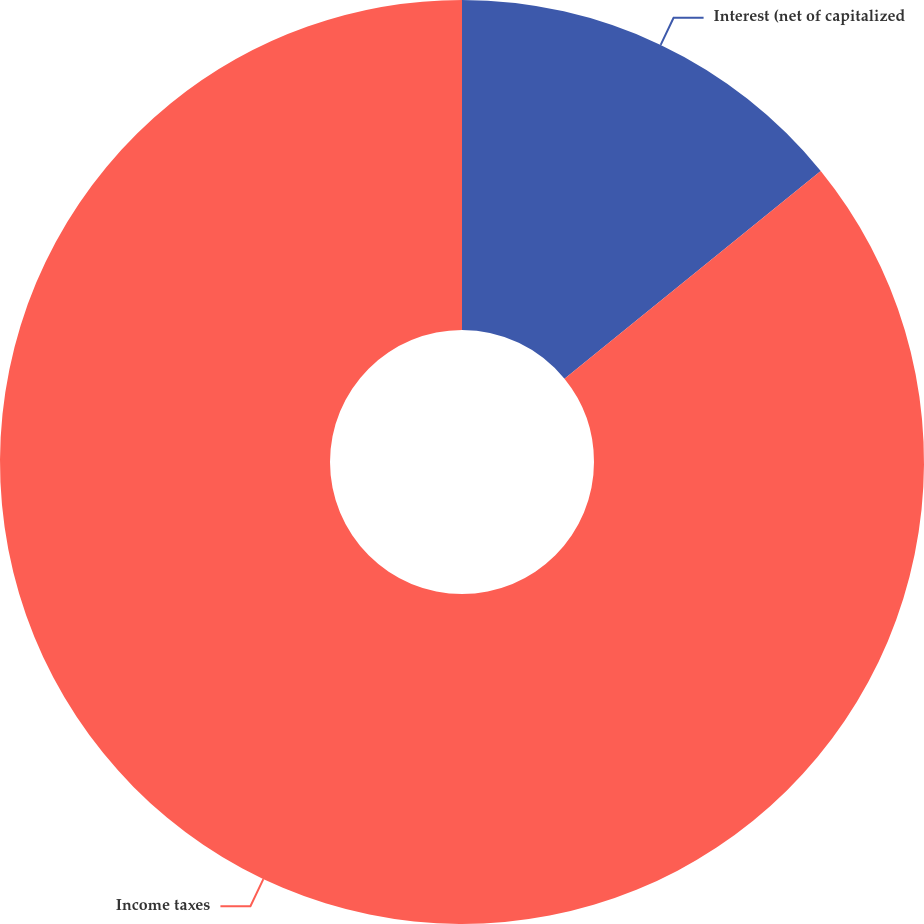<chart> <loc_0><loc_0><loc_500><loc_500><pie_chart><fcel>Interest (net of capitalized<fcel>Income taxes<nl><fcel>14.15%<fcel>85.85%<nl></chart> 